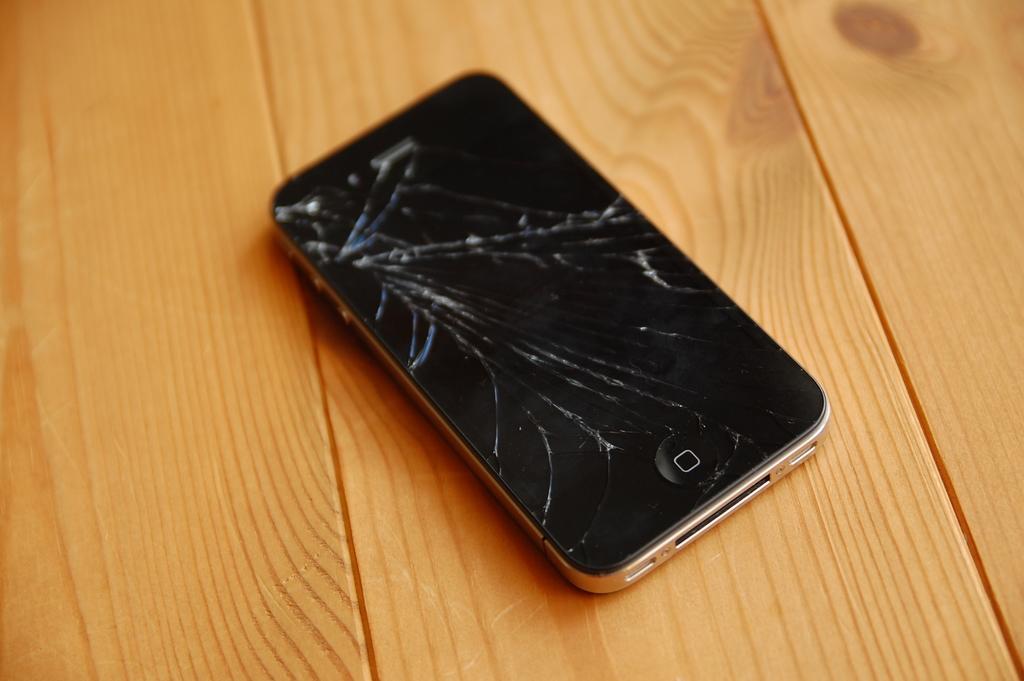Phone is broken?
Offer a terse response. Answering does not require reading text in the image. 